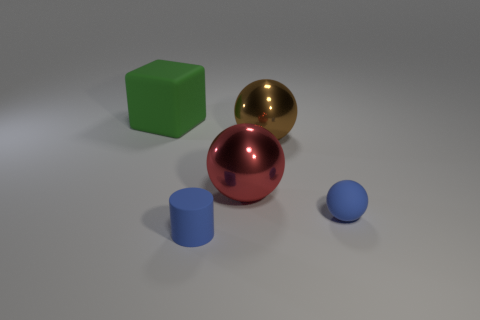Subtract all small matte balls. How many balls are left? 2 Add 4 small yellow shiny cubes. How many objects exist? 9 Subtract all cylinders. How many objects are left? 4 Subtract all red balls. How many balls are left? 2 Subtract 1 spheres. How many spheres are left? 2 Subtract all rubber cylinders. Subtract all big things. How many objects are left? 1 Add 1 rubber cylinders. How many rubber cylinders are left? 2 Add 3 big cyan balls. How many big cyan balls exist? 3 Subtract 0 gray cylinders. How many objects are left? 5 Subtract all gray blocks. Subtract all green cylinders. How many blocks are left? 1 